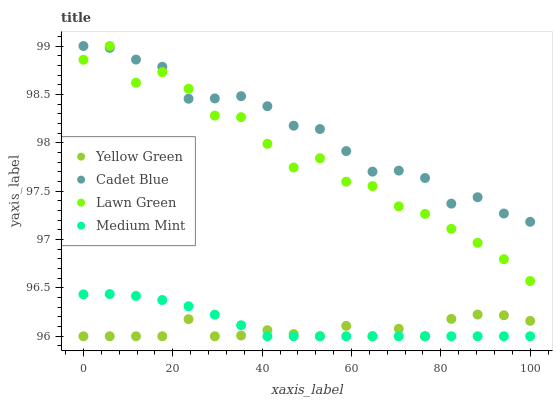Does Yellow Green have the minimum area under the curve?
Answer yes or no. Yes. Does Cadet Blue have the maximum area under the curve?
Answer yes or no. Yes. Does Lawn Green have the minimum area under the curve?
Answer yes or no. No. Does Lawn Green have the maximum area under the curve?
Answer yes or no. No. Is Medium Mint the smoothest?
Answer yes or no. Yes. Is Lawn Green the roughest?
Answer yes or no. Yes. Is Cadet Blue the smoothest?
Answer yes or no. No. Is Cadet Blue the roughest?
Answer yes or no. No. Does Medium Mint have the lowest value?
Answer yes or no. Yes. Does Lawn Green have the lowest value?
Answer yes or no. No. Does Cadet Blue have the highest value?
Answer yes or no. Yes. Does Yellow Green have the highest value?
Answer yes or no. No. Is Yellow Green less than Cadet Blue?
Answer yes or no. Yes. Is Cadet Blue greater than Yellow Green?
Answer yes or no. Yes. Does Medium Mint intersect Yellow Green?
Answer yes or no. Yes. Is Medium Mint less than Yellow Green?
Answer yes or no. No. Is Medium Mint greater than Yellow Green?
Answer yes or no. No. Does Yellow Green intersect Cadet Blue?
Answer yes or no. No. 